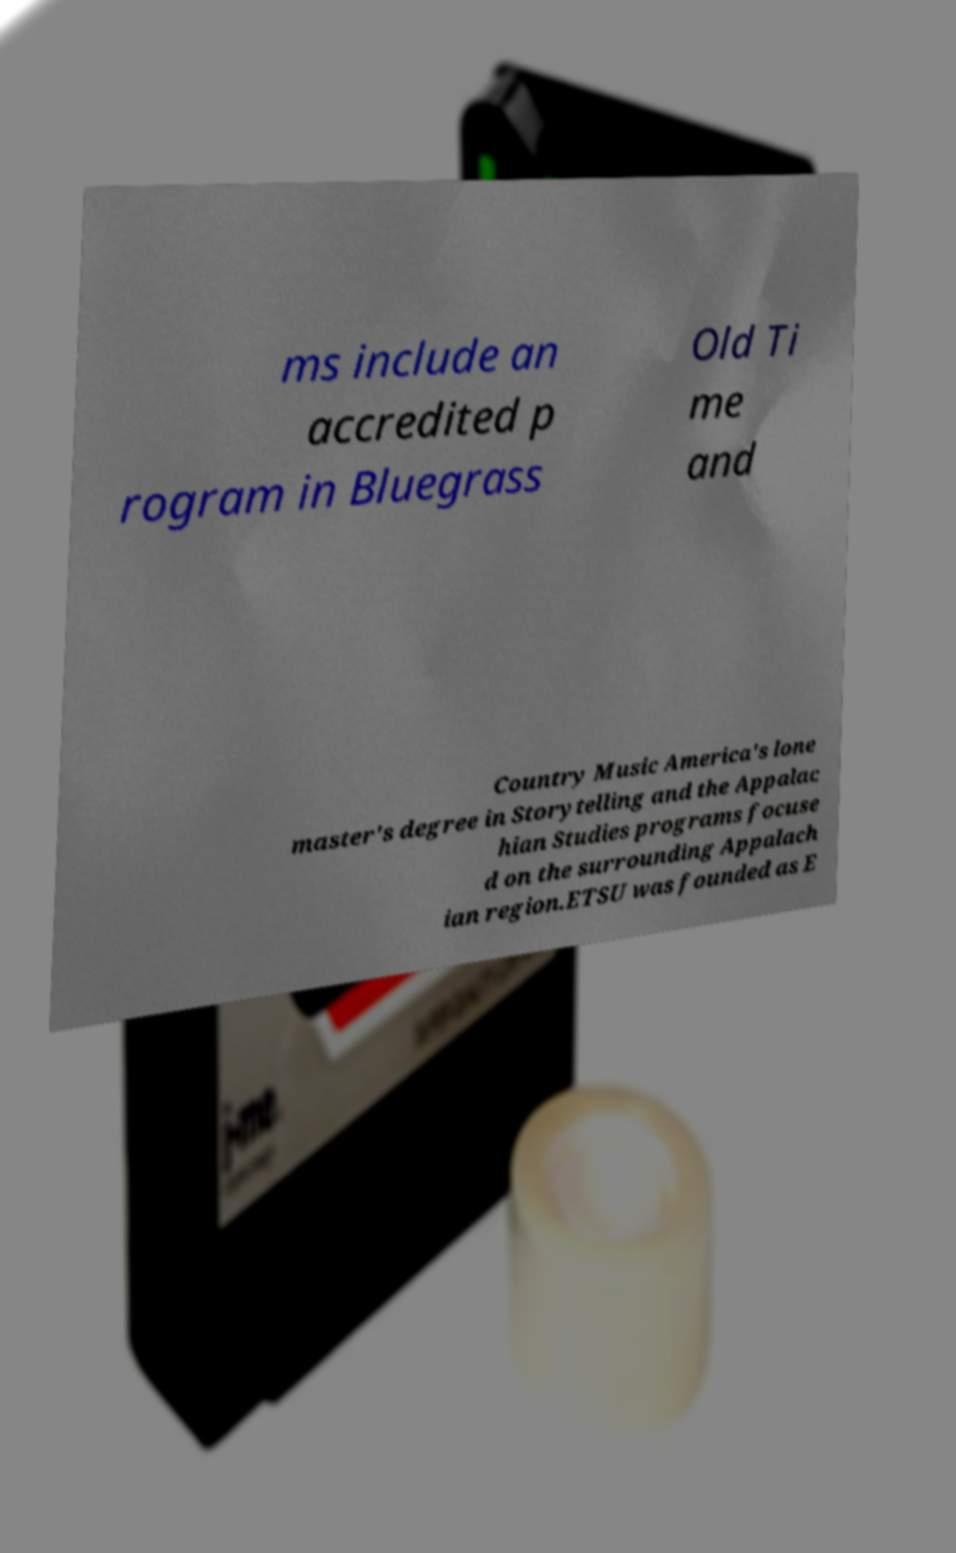Please read and relay the text visible in this image. What does it say? ms include an accredited p rogram in Bluegrass Old Ti me and Country Music America's lone master's degree in Storytelling and the Appalac hian Studies programs focuse d on the surrounding Appalach ian region.ETSU was founded as E 